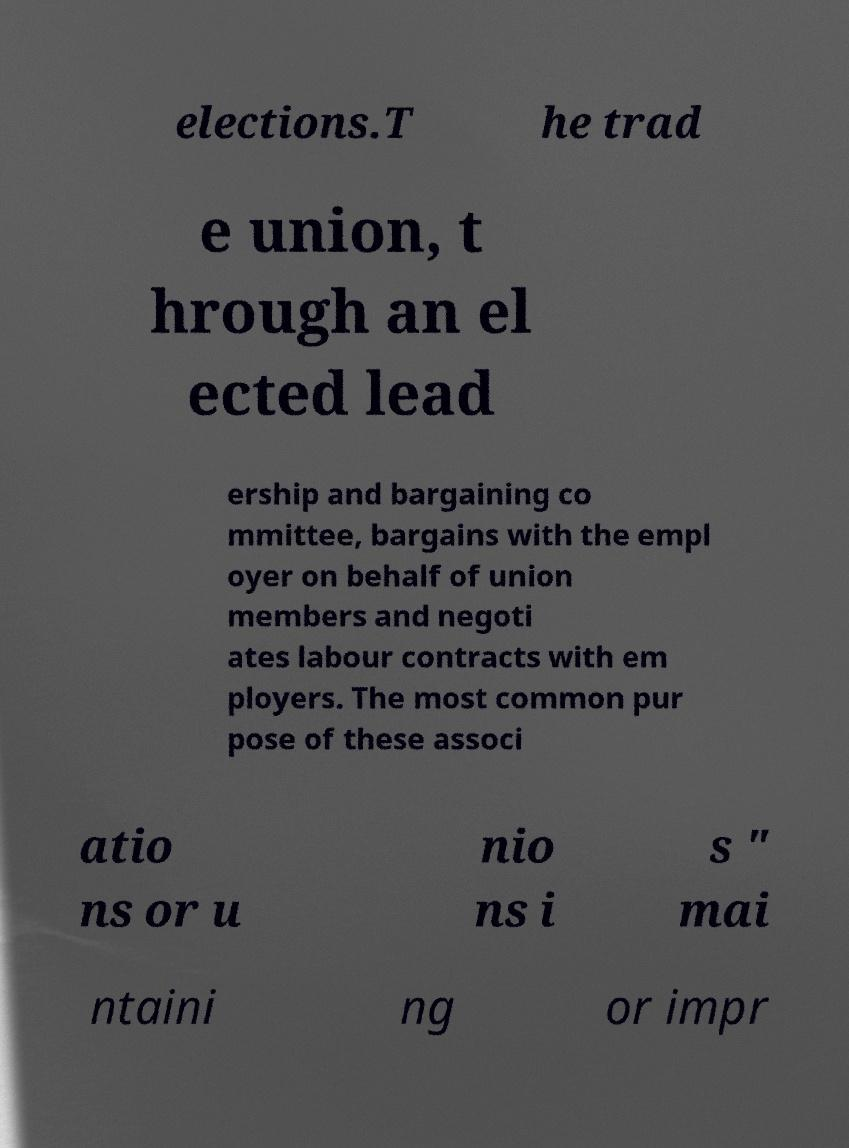Please read and relay the text visible in this image. What does it say? elections.T he trad e union, t hrough an el ected lead ership and bargaining co mmittee, bargains with the empl oyer on behalf of union members and negoti ates labour contracts with em ployers. The most common pur pose of these associ atio ns or u nio ns i s " mai ntaini ng or impr 